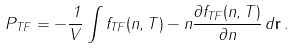Convert formula to latex. <formula><loc_0><loc_0><loc_500><loc_500>P _ { T F } = - \frac { 1 } { V } \int f _ { T F } ( n , T ) - n \frac { \partial f _ { T F } ( n , T ) } { \partial n } \, d { \mathbf r } \, .</formula> 